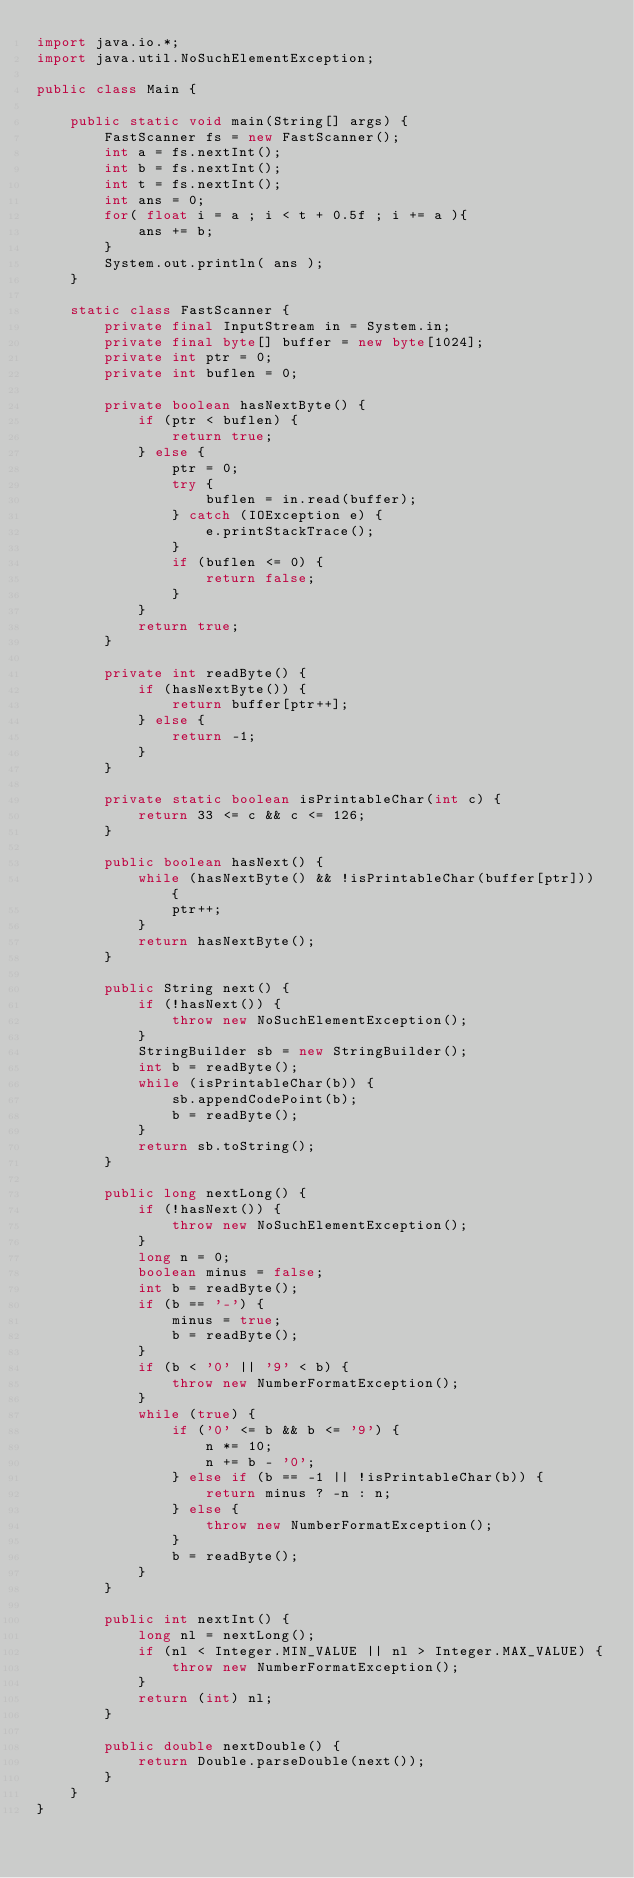<code> <loc_0><loc_0><loc_500><loc_500><_Java_>import java.io.*;
import java.util.NoSuchElementException;

public class Main {

    public static void main(String[] args) {
        FastScanner fs = new FastScanner();
        int a = fs.nextInt();
        int b = fs.nextInt();
        int t = fs.nextInt();
        int ans = 0;
        for( float i = a ; i < t + 0.5f ; i += a ){
            ans += b;
        }
        System.out.println( ans );
    }

    static class FastScanner {
        private final InputStream in = System.in;
        private final byte[] buffer = new byte[1024];
        private int ptr = 0;
        private int buflen = 0;

        private boolean hasNextByte() {
            if (ptr < buflen) {
                return true;
            } else {
                ptr = 0;
                try {
                    buflen = in.read(buffer);
                } catch (IOException e) {
                    e.printStackTrace();
                }
                if (buflen <= 0) {
                    return false;
                }
            }
            return true;
        }

        private int readByte() {
            if (hasNextByte()) {
                return buffer[ptr++];
            } else {
                return -1;
            }
        }

        private static boolean isPrintableChar(int c) {
            return 33 <= c && c <= 126;
        }

        public boolean hasNext() {
            while (hasNextByte() && !isPrintableChar(buffer[ptr])) {
                ptr++;
            }
            return hasNextByte();
        }

        public String next() {
            if (!hasNext()) {
                throw new NoSuchElementException();
            }
            StringBuilder sb = new StringBuilder();
            int b = readByte();
            while (isPrintableChar(b)) {
                sb.appendCodePoint(b);
                b = readByte();
            }
            return sb.toString();
        }

        public long nextLong() {
            if (!hasNext()) {
                throw new NoSuchElementException();
            }
            long n = 0;
            boolean minus = false;
            int b = readByte();
            if (b == '-') {
                minus = true;
                b = readByte();
            }
            if (b < '0' || '9' < b) {
                throw new NumberFormatException();
            }
            while (true) {
                if ('0' <= b && b <= '9') {
                    n *= 10;
                    n += b - '0';
                } else if (b == -1 || !isPrintableChar(b)) {
                    return minus ? -n : n;
                } else {
                    throw new NumberFormatException();
                }
                b = readByte();
            }
        }

        public int nextInt() {
            long nl = nextLong();
            if (nl < Integer.MIN_VALUE || nl > Integer.MAX_VALUE) {
                throw new NumberFormatException();
            }
            return (int) nl;
        }

        public double nextDouble() {
            return Double.parseDouble(next());
        }
    }
}
</code> 